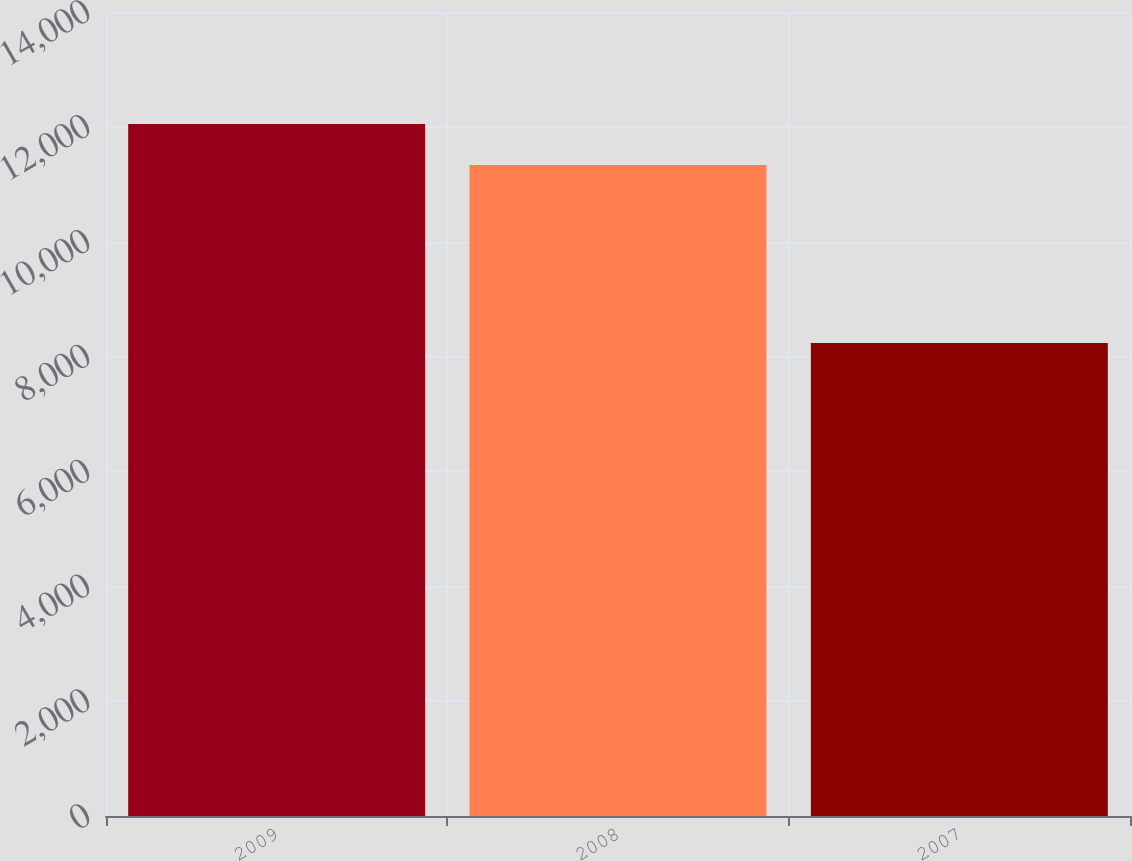<chart> <loc_0><loc_0><loc_500><loc_500><bar_chart><fcel>2009<fcel>2008<fcel>2007<nl><fcel>12050<fcel>11334<fcel>8236<nl></chart> 